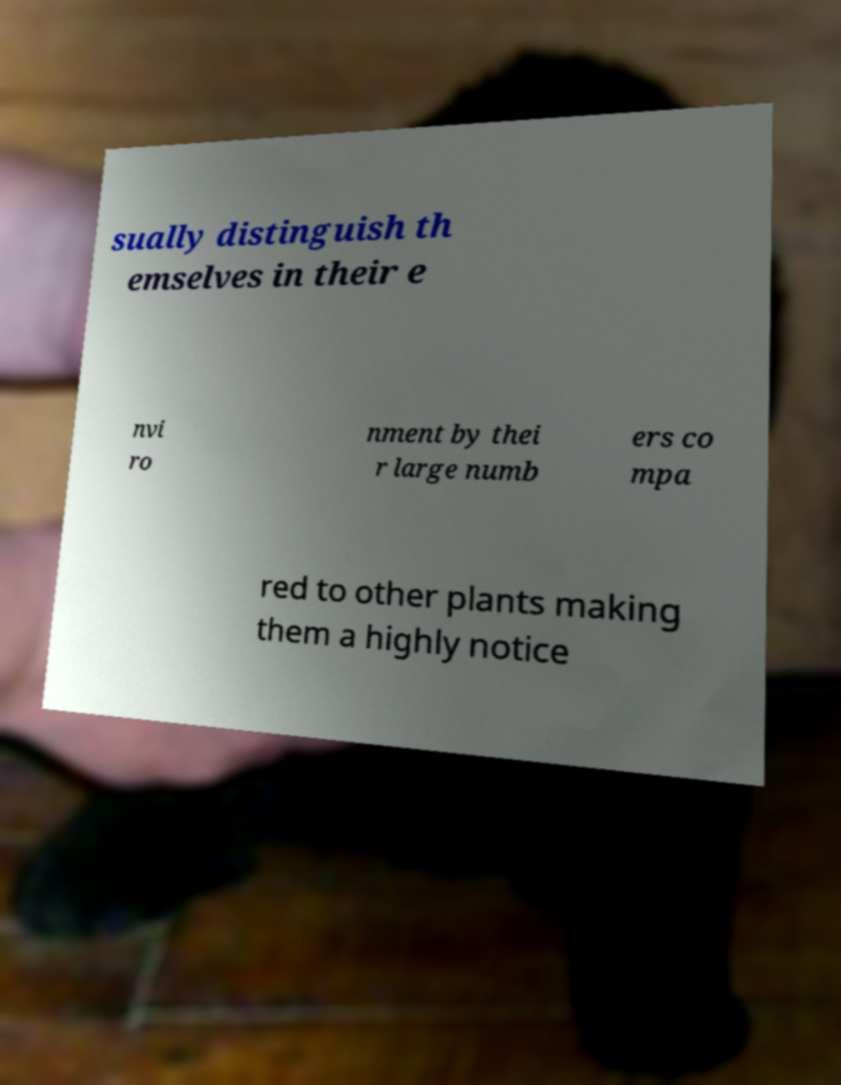Can you accurately transcribe the text from the provided image for me? sually distinguish th emselves in their e nvi ro nment by thei r large numb ers co mpa red to other plants making them a highly notice 